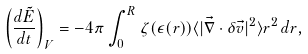<formula> <loc_0><loc_0><loc_500><loc_500>\left ( \frac { d \tilde { E } } { d t } \right ) _ { V } = - 4 \pi \int _ { 0 } ^ { R } \zeta ( \epsilon ( r ) ) \langle | \vec { \nabla } \cdot \delta \vec { v } | ^ { 2 } \rangle r ^ { 2 } \, d r ,</formula> 